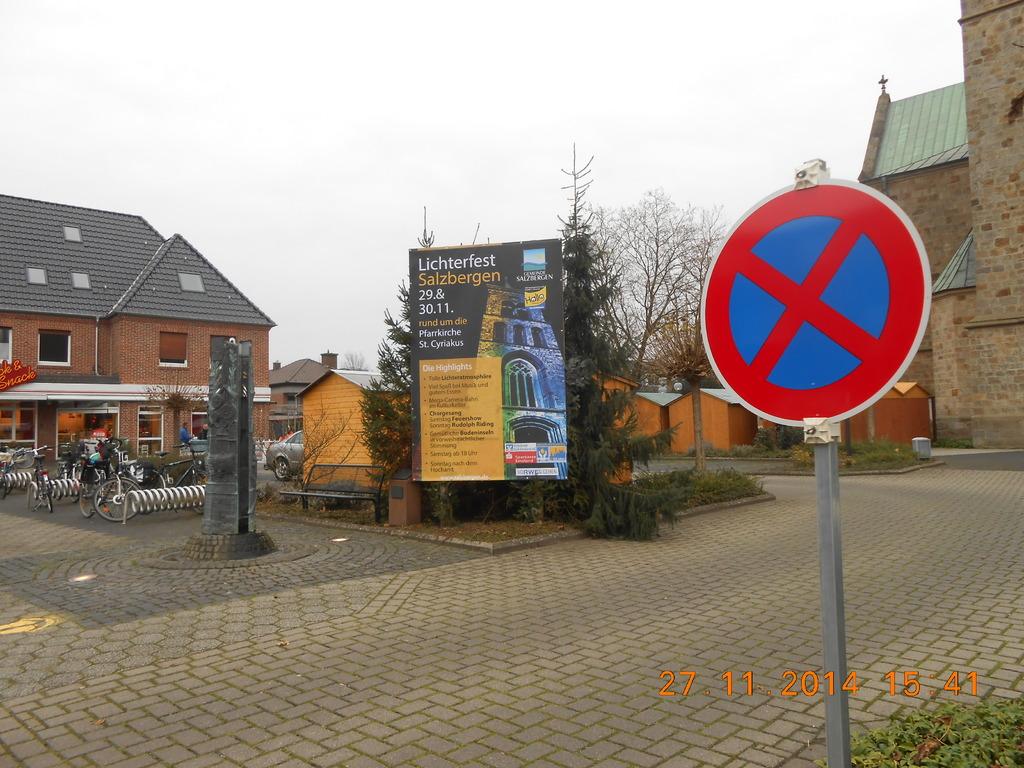What's the date of this photo?
Your answer should be compact. 27 11 2014. 